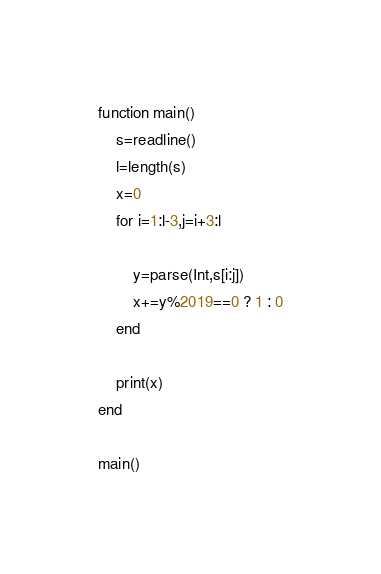Convert code to text. <code><loc_0><loc_0><loc_500><loc_500><_Julia_>function main()
    s=readline()
    l=length(s)
    x=0
    for i=1:l-3,j=i+3:l
        
        y=parse(Int,s[i:j])
        x+=y%2019==0 ? 1 : 0
    end

    print(x)
end

main()</code> 